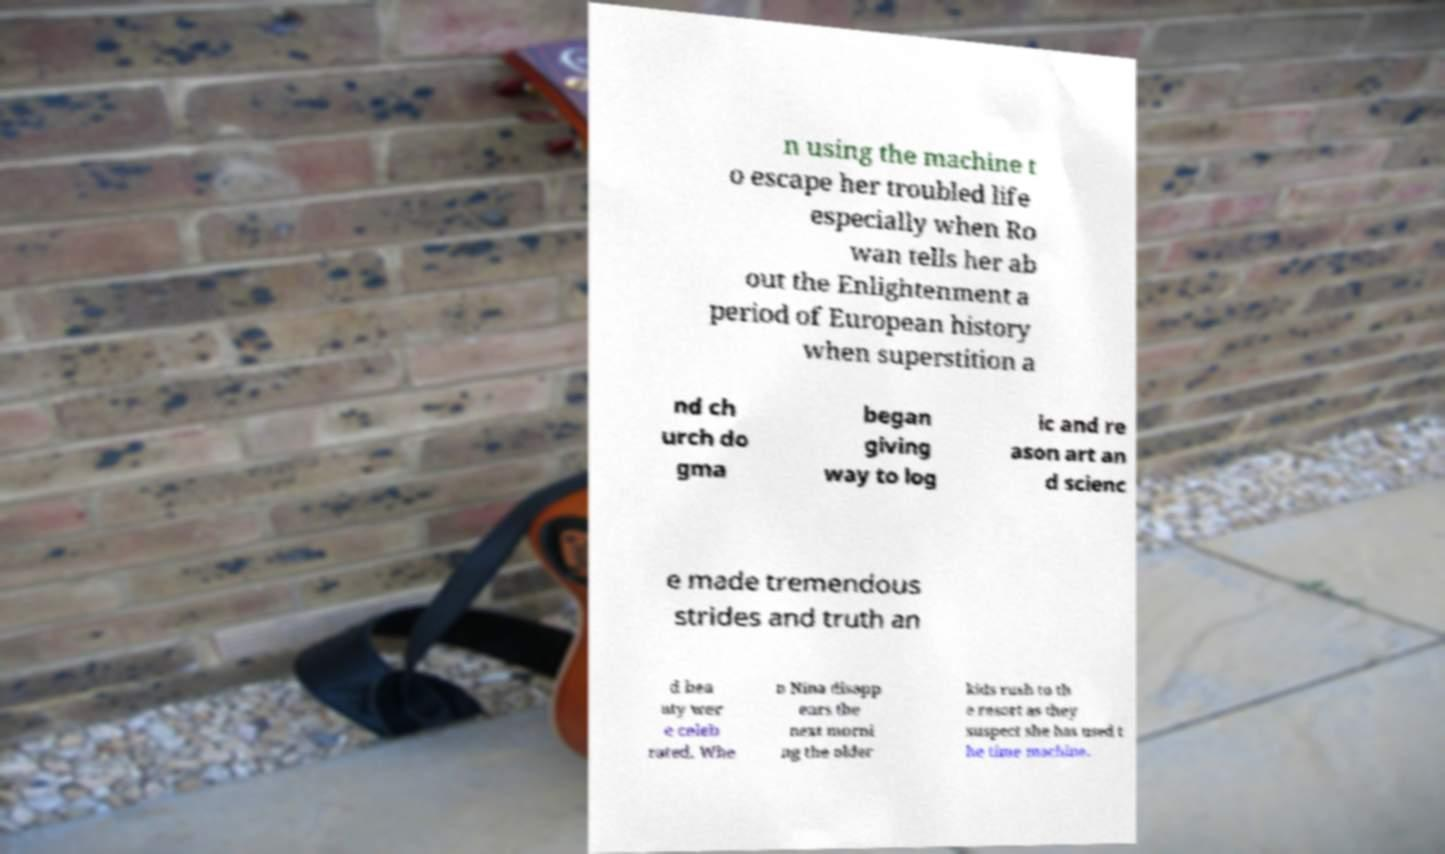Can you read and provide the text displayed in the image?This photo seems to have some interesting text. Can you extract and type it out for me? n using the machine t o escape her troubled life especially when Ro wan tells her ab out the Enlightenment a period of European history when superstition a nd ch urch do gma began giving way to log ic and re ason art an d scienc e made tremendous strides and truth an d bea uty wer e celeb rated. Whe n Nina disapp ears the next morni ng the older kids rush to th e resort as they suspect she has used t he time machine. 